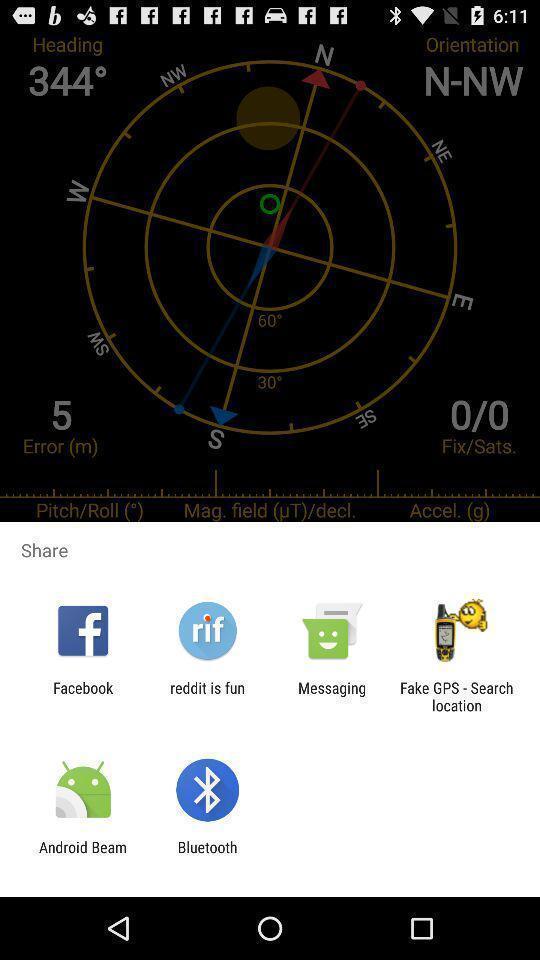Give me a summary of this screen capture. Popup displaying multiple options to select. 